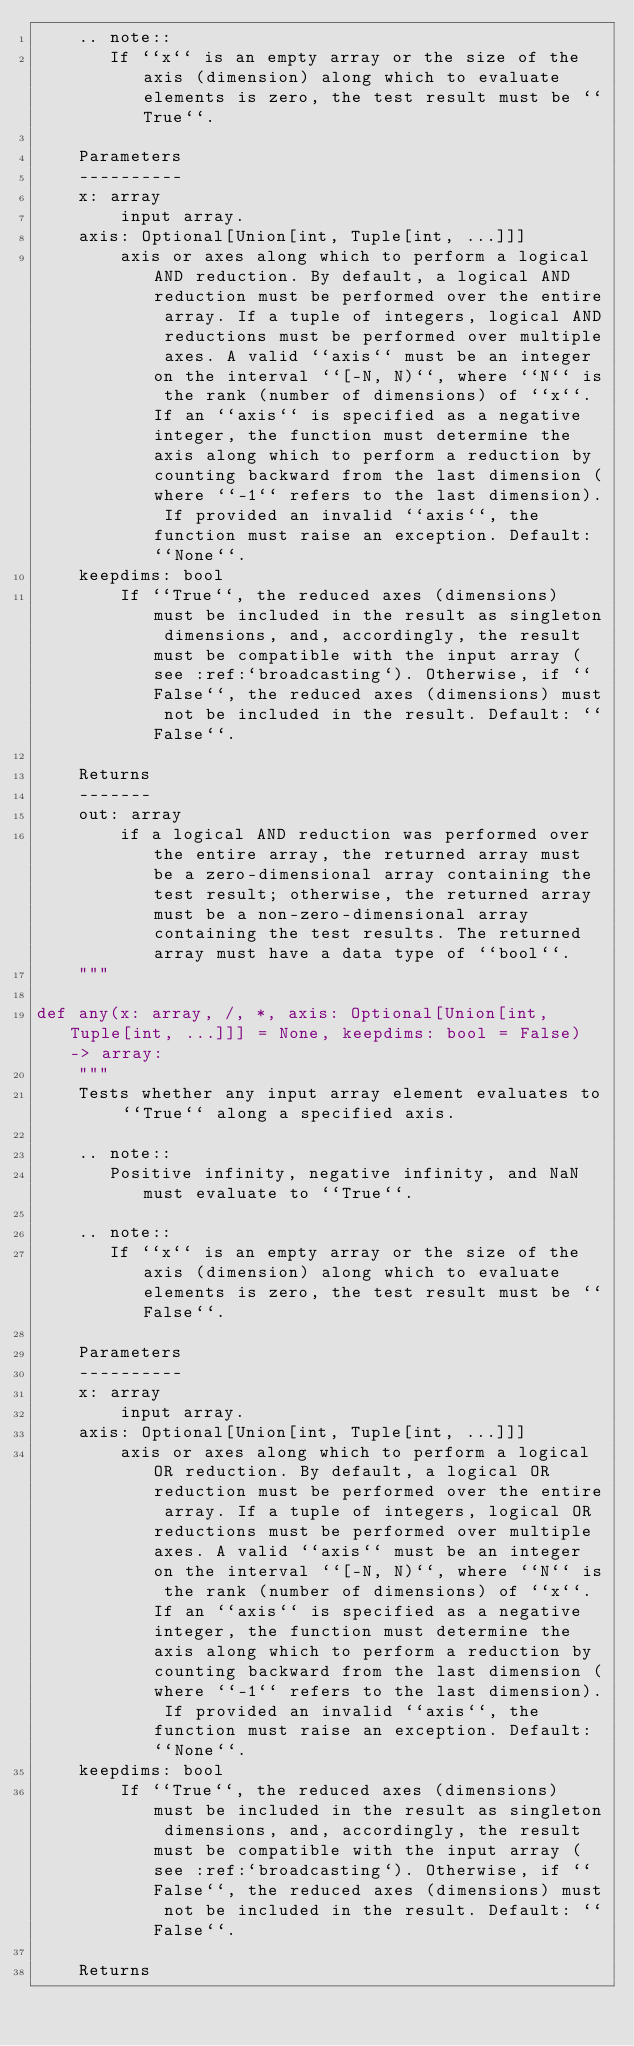Convert code to text. <code><loc_0><loc_0><loc_500><loc_500><_Python_>    .. note::
       If ``x`` is an empty array or the size of the axis (dimension) along which to evaluate elements is zero, the test result must be ``True``.

    Parameters
    ----------
    x: array
        input array.
    axis: Optional[Union[int, Tuple[int, ...]]]
        axis or axes along which to perform a logical AND reduction. By default, a logical AND reduction must be performed over the entire array. If a tuple of integers, logical AND reductions must be performed over multiple axes. A valid ``axis`` must be an integer on the interval ``[-N, N)``, where ``N`` is the rank (number of dimensions) of ``x``. If an ``axis`` is specified as a negative integer, the function must determine the axis along which to perform a reduction by counting backward from the last dimension (where ``-1`` refers to the last dimension). If provided an invalid ``axis``, the function must raise an exception. Default: ``None``.
    keepdims: bool
        If ``True``, the reduced axes (dimensions) must be included in the result as singleton dimensions, and, accordingly, the result must be compatible with the input array (see :ref:`broadcasting`). Otherwise, if ``False``, the reduced axes (dimensions) must not be included in the result. Default: ``False``.

    Returns
    -------
    out: array
        if a logical AND reduction was performed over the entire array, the returned array must be a zero-dimensional array containing the test result; otherwise, the returned array must be a non-zero-dimensional array containing the test results. The returned array must have a data type of ``bool``.
    """

def any(x: array, /, *, axis: Optional[Union[int, Tuple[int, ...]]] = None, keepdims: bool = False) -> array:
    """
    Tests whether any input array element evaluates to ``True`` along a specified axis.

    .. note::
       Positive infinity, negative infinity, and NaN must evaluate to ``True``.

    .. note::
       If ``x`` is an empty array or the size of the axis (dimension) along which to evaluate elements is zero, the test result must be ``False``.

    Parameters
    ----------
    x: array
        input array.
    axis: Optional[Union[int, Tuple[int, ...]]]
        axis or axes along which to perform a logical OR reduction. By default, a logical OR reduction must be performed over the entire array. If a tuple of integers, logical OR reductions must be performed over multiple axes. A valid ``axis`` must be an integer on the interval ``[-N, N)``, where ``N`` is the rank (number of dimensions) of ``x``. If an ``axis`` is specified as a negative integer, the function must determine the axis along which to perform a reduction by counting backward from the last dimension (where ``-1`` refers to the last dimension). If provided an invalid ``axis``, the function must raise an exception. Default: ``None``.
    keepdims: bool
        If ``True``, the reduced axes (dimensions) must be included in the result as singleton dimensions, and, accordingly, the result must be compatible with the input array (see :ref:`broadcasting`). Otherwise, if ``False``, the reduced axes (dimensions) must not be included in the result. Default: ``False``.

    Returns</code> 